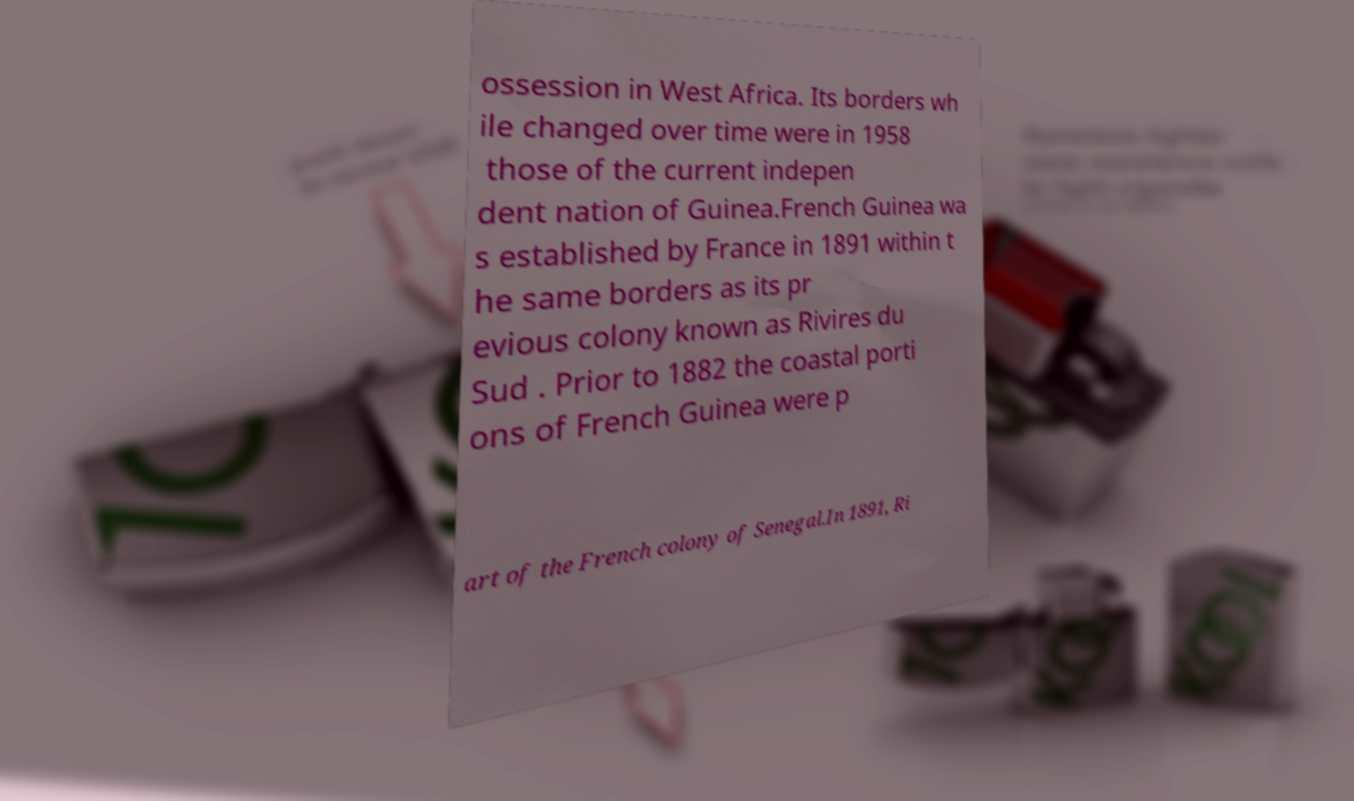Can you read and provide the text displayed in the image?This photo seems to have some interesting text. Can you extract and type it out for me? ossession in West Africa. Its borders wh ile changed over time were in 1958 those of the current indepen dent nation of Guinea.French Guinea wa s established by France in 1891 within t he same borders as its pr evious colony known as Rivires du Sud . Prior to 1882 the coastal porti ons of French Guinea were p art of the French colony of Senegal.In 1891, Ri 